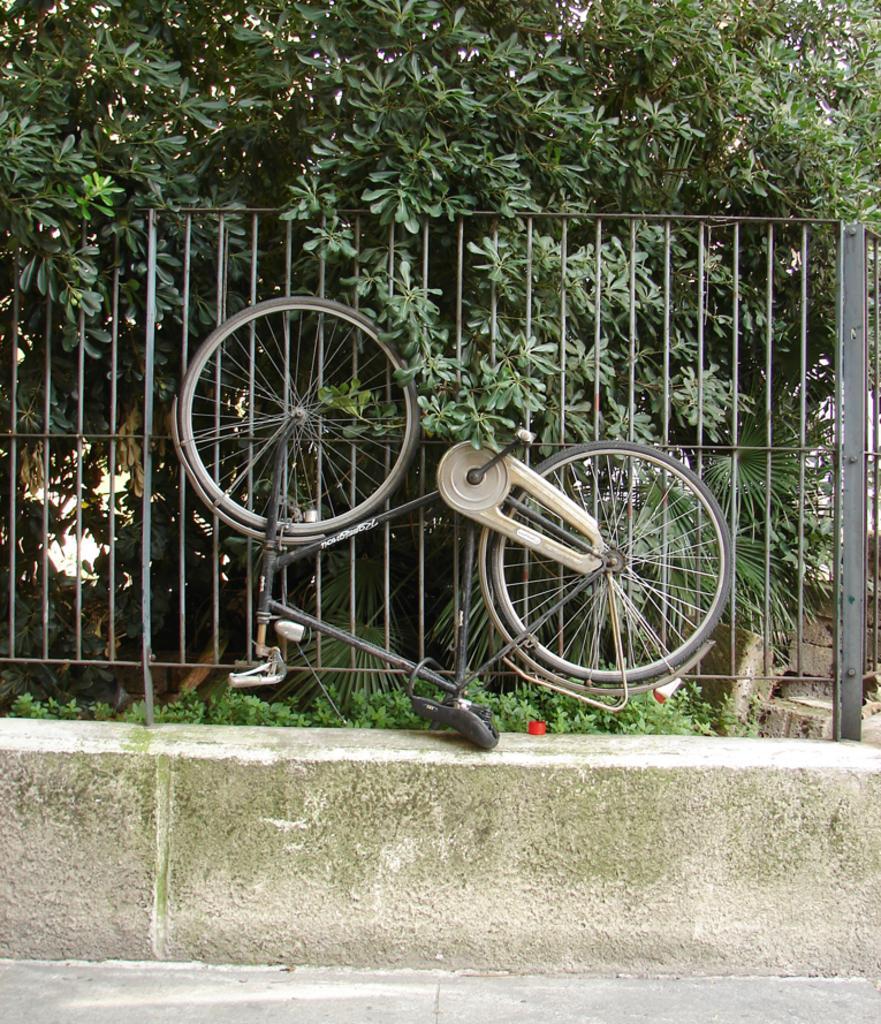Can you describe this image briefly? This picture is clicked outside. In this center we can see a bicycle, metal rods and we can see the plants and trees. In the foreground we can see the ground and we can see some other objects. 